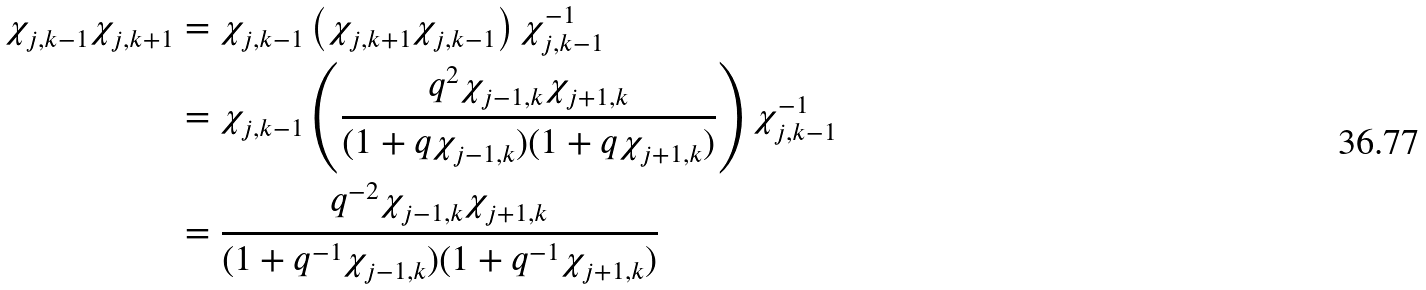<formula> <loc_0><loc_0><loc_500><loc_500>\chi _ { j , k - 1 } \chi _ { j , k + 1 } & = \chi _ { j , k - 1 } \left ( \chi _ { j , k + 1 } \chi _ { j , k - 1 } \right ) \chi _ { j , k - 1 } ^ { - 1 } \\ & = \chi _ { j , k - 1 } \left ( \frac { q ^ { 2 } \chi _ { j - 1 , k } \chi _ { j + 1 , k } } { ( 1 + q \chi _ { j - 1 , k } ) ( 1 + q \chi _ { j + 1 , k } ) } \right ) \chi _ { j , k - 1 } ^ { - 1 } \\ & = \frac { q ^ { - 2 } \chi _ { j - 1 , k } \chi _ { j + 1 , k } } { ( 1 + q ^ { - 1 } \chi _ { j - 1 , k } ) ( 1 + q ^ { - 1 } \chi _ { j + 1 , k } ) }</formula> 